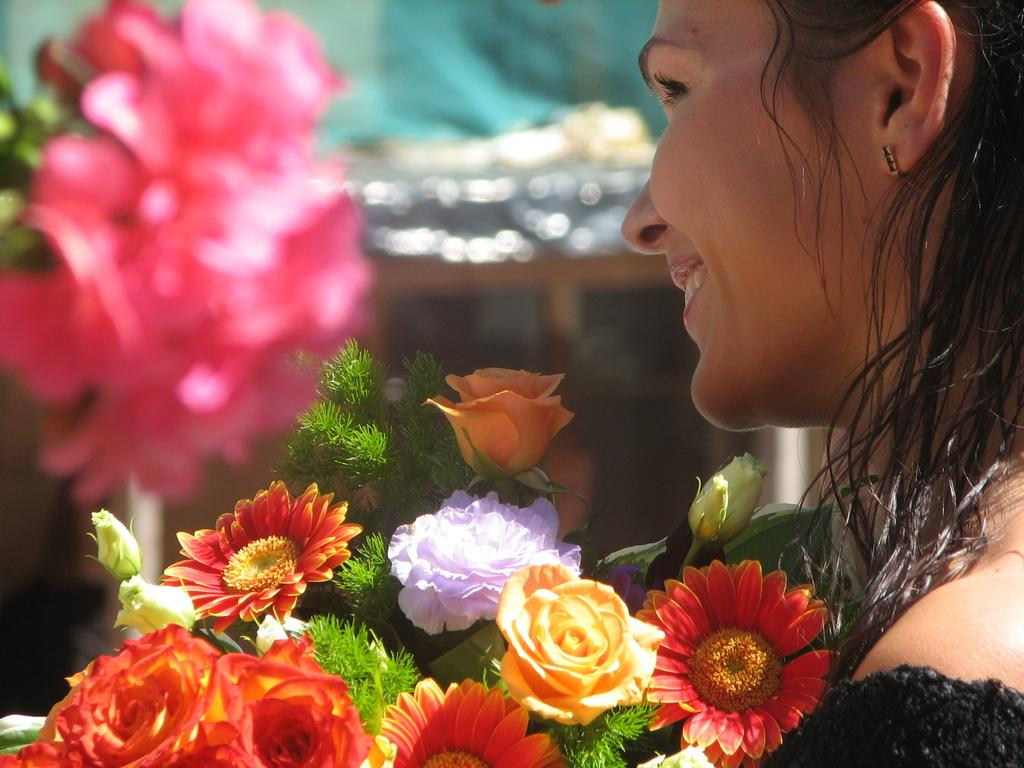Who is present in the image? There is a woman in the image. What is the woman's expression? The woman is smiling. What can be seen besides the woman in the image? There is a bunch of colorful flowers in the image. Can you describe the background of the image? The background of the image is blurred. What type of property does the woman own in the image? There is no information about property ownership in the image. 